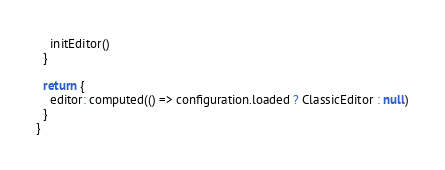<code> <loc_0><loc_0><loc_500><loc_500><_JavaScript_>    initEditor()
  }

  return {
    editor: computed(() => configuration.loaded ? ClassicEditor : null)
  }
}
</code> 